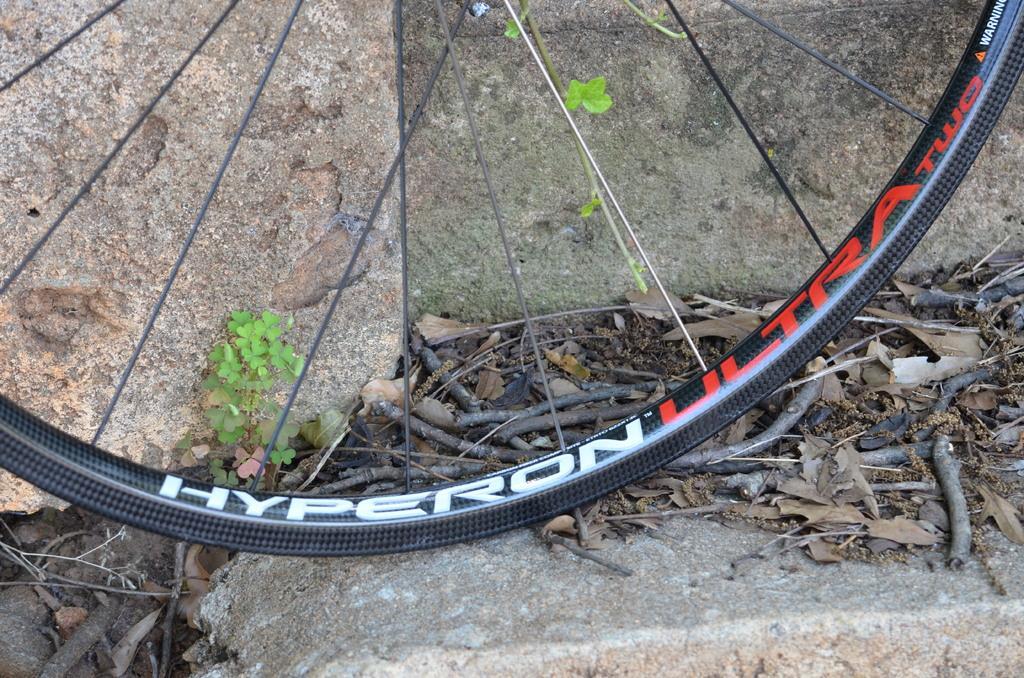Please provide a concise description of this image. In this image we can see a wheel of a bicycle. In the background there are rocks and we can see plants. There are twigs. 